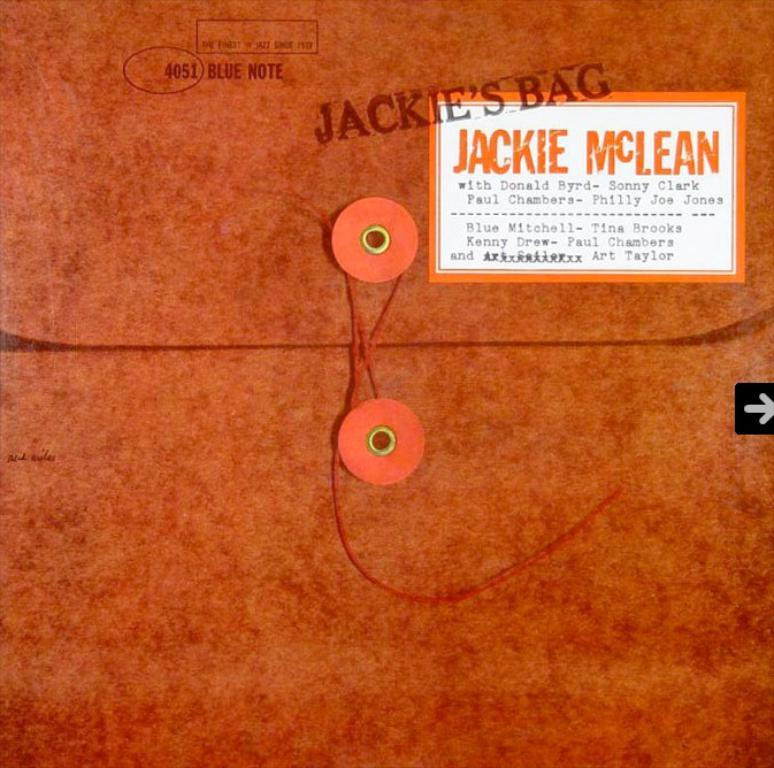<image>
Write a terse but informative summary of the picture. a brown envelope with a red tie and words Jackie's Bag on it 